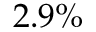Convert formula to latex. <formula><loc_0><loc_0><loc_500><loc_500>2 . 9 \%</formula> 